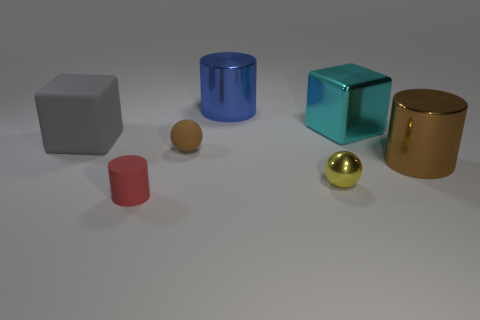Add 1 matte cubes. How many objects exist? 8 Subtract all blocks. How many objects are left? 5 Add 4 metal cylinders. How many metal cylinders exist? 6 Subtract 1 blue cylinders. How many objects are left? 6 Subtract all blue things. Subtract all large gray matte objects. How many objects are left? 5 Add 6 tiny yellow metal spheres. How many tiny yellow metal spheres are left? 7 